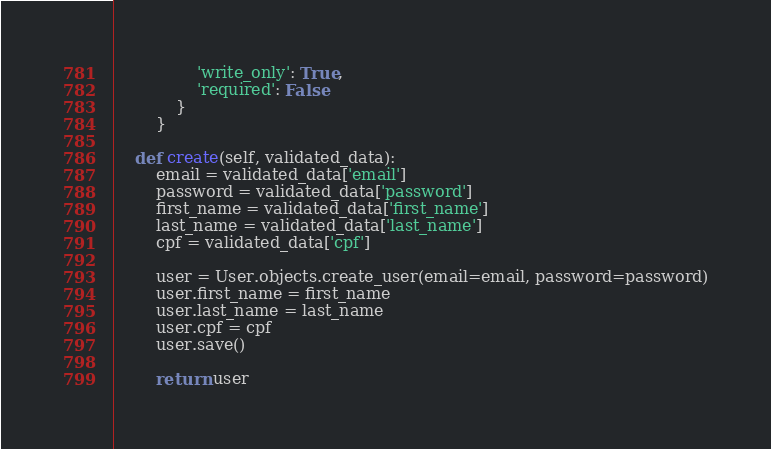<code> <loc_0><loc_0><loc_500><loc_500><_Python_>                'write_only': True,
                'required': False
            }
        }

    def create(self, validated_data):
        email = validated_data['email']
        password = validated_data['password']
        first_name = validated_data['first_name']
        last_name = validated_data['last_name']
        cpf = validated_data['cpf']

        user = User.objects.create_user(email=email, password=password)
        user.first_name = first_name
        user.last_name = last_name
        user.cpf = cpf
        user.save()

        return user
</code> 